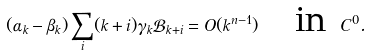<formula> <loc_0><loc_0><loc_500><loc_500>( \alpha _ { k } - \beta _ { k } ) \sum _ { i } ( k + i ) \gamma _ { k } \mathcal { B } _ { k + i } = O ( k ^ { n - 1 } ) \quad \text {in } C ^ { 0 } .</formula> 